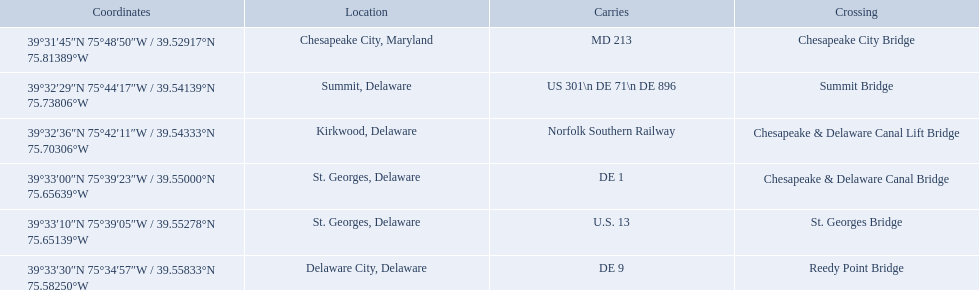What are the carries of the crossing located in summit, delaware? US 301\n DE 71\n DE 896. Based on the answer in the previous question, what is the name of the crossing? Summit Bridge. 